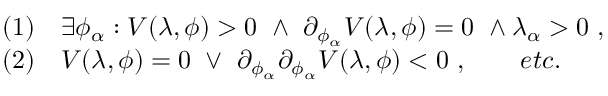Convert formula to latex. <formula><loc_0><loc_0><loc_500><loc_500>\begin{array} { r l } & { ( 1 ) \quad \exists \phi _ { \alpha } \colon V ( \lambda , \phi ) > 0 \ \land \ \partial _ { \phi _ { \alpha } } V ( \lambda , \phi ) = 0 \ \land \lambda _ { \alpha } > 0 \ , } \\ & { ( 2 ) \quad V ( \lambda , \phi ) = 0 \ \lor \ \partial _ { \phi _ { \alpha } } \partial _ { \phi _ { \alpha } } V ( \lambda , \phi ) < 0 \ , \quad e t c . } \end{array}</formula> 